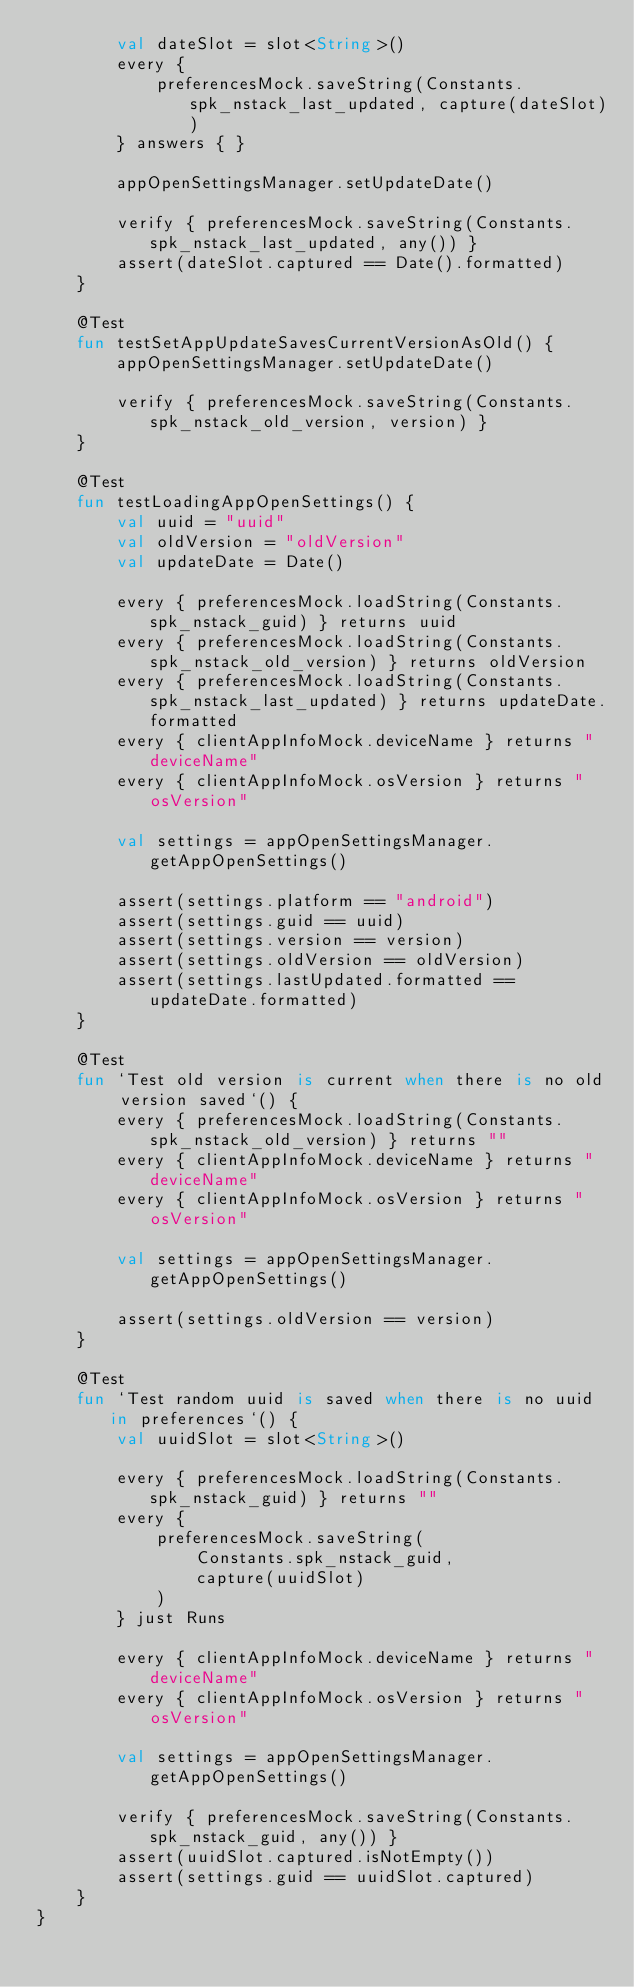Convert code to text. <code><loc_0><loc_0><loc_500><loc_500><_Kotlin_>        val dateSlot = slot<String>()
        every {
            preferencesMock.saveString(Constants.spk_nstack_last_updated, capture(dateSlot))
        } answers { }

        appOpenSettingsManager.setUpdateDate()

        verify { preferencesMock.saveString(Constants.spk_nstack_last_updated, any()) }
        assert(dateSlot.captured == Date().formatted)
    }

    @Test
    fun testSetAppUpdateSavesCurrentVersionAsOld() {
        appOpenSettingsManager.setUpdateDate()

        verify { preferencesMock.saveString(Constants.spk_nstack_old_version, version) }
    }

    @Test
    fun testLoadingAppOpenSettings() {
        val uuid = "uuid"
        val oldVersion = "oldVersion"
        val updateDate = Date()

        every { preferencesMock.loadString(Constants.spk_nstack_guid) } returns uuid
        every { preferencesMock.loadString(Constants.spk_nstack_old_version) } returns oldVersion
        every { preferencesMock.loadString(Constants.spk_nstack_last_updated) } returns updateDate.formatted
        every { clientAppInfoMock.deviceName } returns "deviceName"
        every { clientAppInfoMock.osVersion } returns "osVersion"

        val settings = appOpenSettingsManager.getAppOpenSettings()

        assert(settings.platform == "android")
        assert(settings.guid == uuid)
        assert(settings.version == version)
        assert(settings.oldVersion == oldVersion)
        assert(settings.lastUpdated.formatted == updateDate.formatted)
    }

    @Test
    fun `Test old version is current when there is no old version saved`() {
        every { preferencesMock.loadString(Constants.spk_nstack_old_version) } returns ""
        every { clientAppInfoMock.deviceName } returns "deviceName"
        every { clientAppInfoMock.osVersion } returns "osVersion"

        val settings = appOpenSettingsManager.getAppOpenSettings()

        assert(settings.oldVersion == version)
    }

    @Test
    fun `Test random uuid is saved when there is no uuid in preferences`() {
        val uuidSlot = slot<String>()

        every { preferencesMock.loadString(Constants.spk_nstack_guid) } returns ""
        every {
            preferencesMock.saveString(
                Constants.spk_nstack_guid,
                capture(uuidSlot)
            )
        } just Runs

        every { clientAppInfoMock.deviceName } returns "deviceName"
        every { clientAppInfoMock.osVersion } returns "osVersion"

        val settings = appOpenSettingsManager.getAppOpenSettings()

        verify { preferencesMock.saveString(Constants.spk_nstack_guid, any()) }
        assert(uuidSlot.captured.isNotEmpty())
        assert(settings.guid == uuidSlot.captured)
    }
}
</code> 